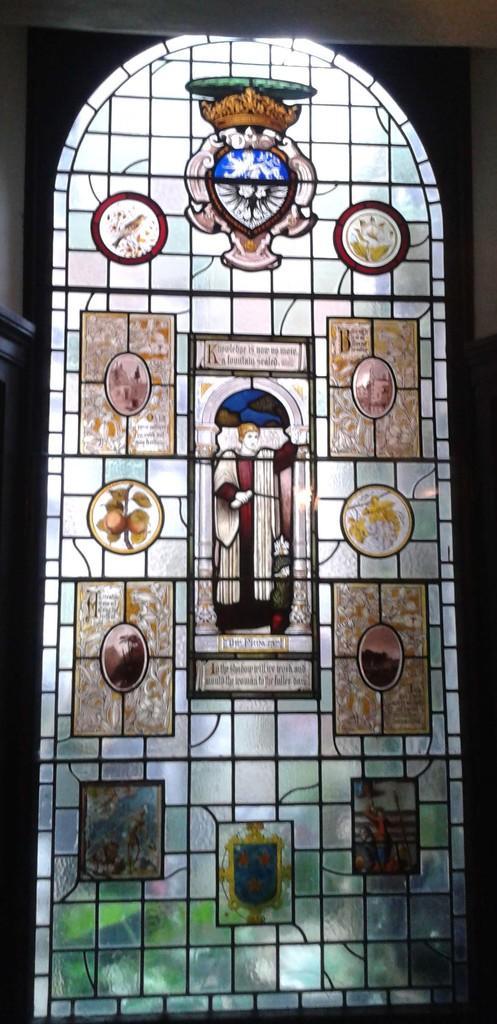Can you describe this image briefly? In this image I can see a colorful design door. 